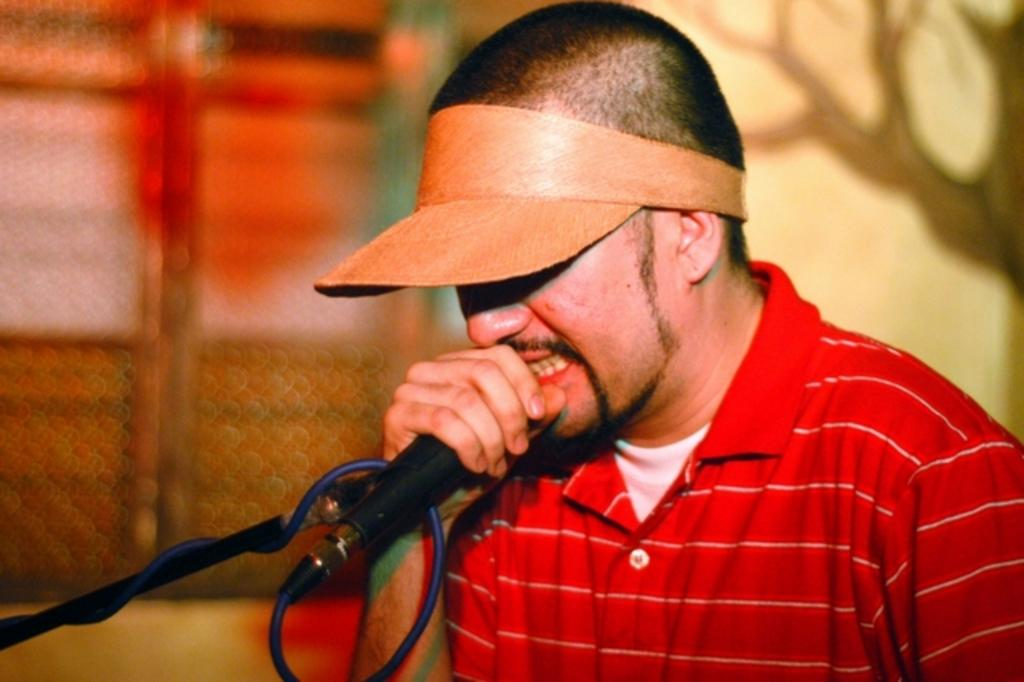What is the man in the image doing? The man is singing in the image. How is the man amplifying his voice while singing? The man is using a microphone in the image. What type of approval is the man seeking from the audience in the image? There is no indication in the image that the man is seeking approval from the audience. 